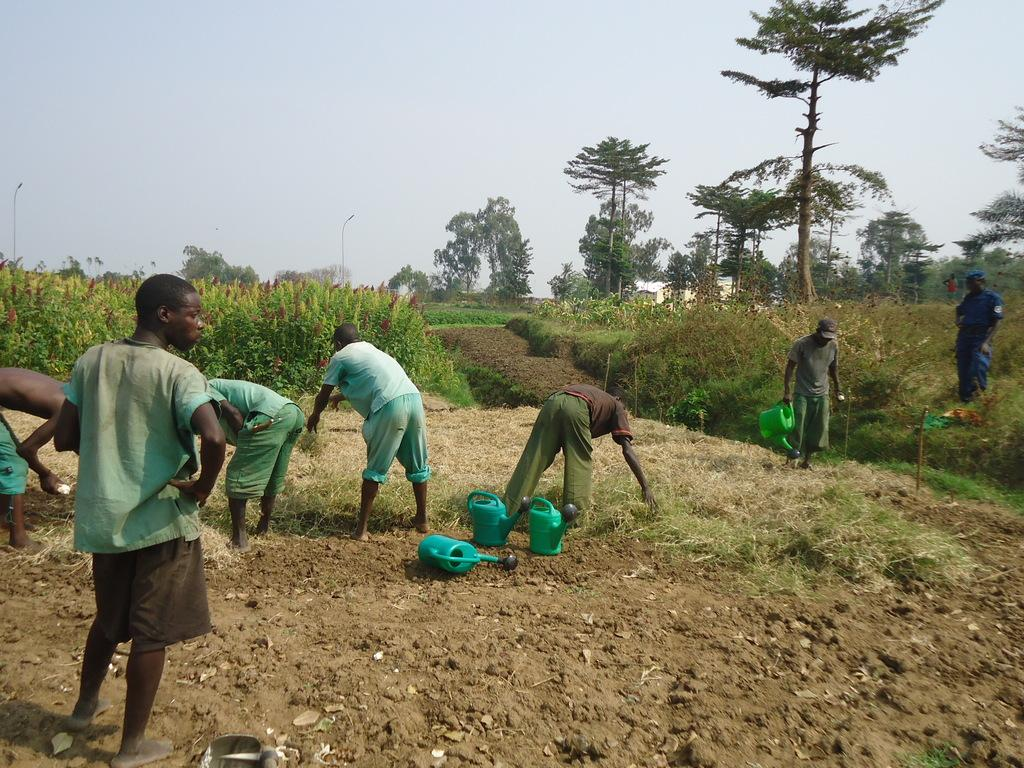How many people are in the image? There are people in the image, but the exact number is not specified. What is the man in the image doing? A man is standing in the image. Who is holding a water can in the image? A person is holding a water can in the image. Can you describe the objects on the surface in the image? There are water cans on the surface in the image. What type of vegetation is present in the image? Grass is present in the image. What can be seen in the background of the image? Trees, plants, and the sky are visible in the background of the image. How many clocks are visible in the image? There are no clocks visible in the image. What type of fireman is present in the image? There is no fireman present in the image. 